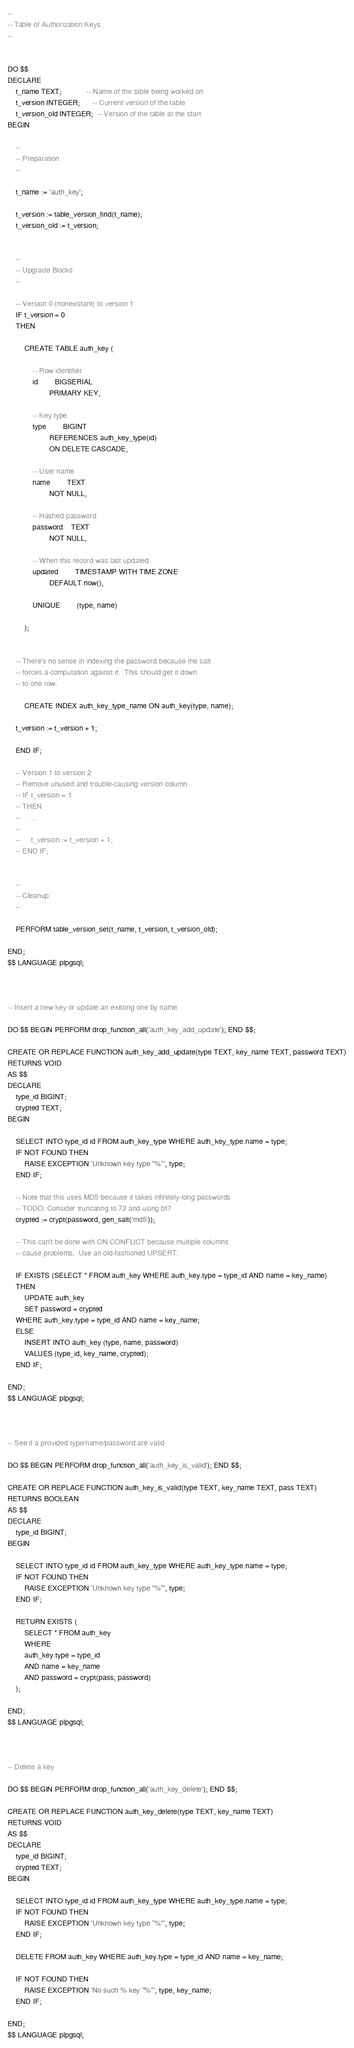Convert code to text. <code><loc_0><loc_0><loc_500><loc_500><_SQL_>--
-- Table of Authorization Keys
--


DO $$
DECLARE
    t_name TEXT;            -- Name of the table being worked on
    t_version INTEGER;      -- Current version of the table
    t_version_old INTEGER;  -- Version of the table at the start
BEGIN

    --
    -- Preparation
    --

    t_name := 'auth_key';

    t_version := table_version_find(t_name);
    t_version_old := t_version;


    --
    -- Upgrade Blocks
    --

    -- Version 0 (nonexistant) to version 1
    IF t_version = 0
    THEN

        CREATE TABLE auth_key (

        	-- Row identifier
        	id		BIGSERIAL
        			PRIMARY KEY,

        	-- Key type
        	type		BIGINT
        			REFERENCES auth_key_type(id)
        			ON DELETE CASCADE,

        	-- User name
        	name		TEXT
        			NOT NULL,

        	-- Hashed password
        	password	TEXT
        			NOT NULL,

        	-- When this record was last updated
        	updated		TIMESTAMP WITH TIME ZONE
        			DEFAULT now(),

        	UNIQUE		(type, name)

        );


	-- There's no sense in indexing the password because the salt
	-- forces a computation against it.  This should get it down
	-- to one row.

        CREATE INDEX auth_key_type_name ON auth_key(type, name);

	t_version := t_version + 1;

    END IF;

    -- Version 1 to version 2
    -- Remove unused and trouble-causing version column
    -- IF t_version = 1
    -- THEN
    --     ...
    -- 
    --     t_version := t_version + 1;
    -- END IF;


    --
    -- Cleanup
    --

    PERFORM table_version_set(t_name, t_version, t_version_old);

END;
$$ LANGUAGE plpgsql;



-- Insert a new key or update an existing one by name

DO $$ BEGIN PERFORM drop_function_all('auth_key_add_update'); END $$;

CREATE OR REPLACE FUNCTION auth_key_add_update(type TEXT, key_name TEXT, password TEXT)
RETURNS VOID
AS $$
DECLARE
    type_id BIGINT;
    crypted TEXT;
BEGIN

    SELECT INTO type_id id FROM auth_key_type WHERE auth_key_type.name = type;
    IF NOT FOUND THEN
        RAISE EXCEPTION 'Unknown key type "%"', type;
    END IF;

    -- Note that this uses MD5 because it takes infinitely-long passwords
    -- TODO: Consider truncating to 72 and using bf?
    crypted := crypt(password, gen_salt('md5'));

    -- This can't be done with ON CONFLICT because multiple columns
    -- cause problems.  Use an old-fashioned UPSERT.

    IF EXISTS (SELECT * FROM auth_key WHERE auth_key.type = type_id AND name = key_name)
    THEN
        UPDATE auth_key
        SET password = crypted
	WHERE auth_key.type = type_id AND name = key_name;
    ELSE
        INSERT INTO auth_key (type, name, password)
        VALUES (type_id, key_name, crypted);
    END IF;

END;
$$ LANGUAGE plpgsql;



-- See if a provided type/name/password are valid

DO $$ BEGIN PERFORM drop_function_all('auth_key_is_valid'); END $$;

CREATE OR REPLACE FUNCTION auth_key_is_valid(type TEXT, key_name TEXT, pass TEXT)
RETURNS BOOLEAN
AS $$
DECLARE
    type_id BIGINT;
BEGIN

    SELECT INTO type_id id FROM auth_key_type WHERE auth_key_type.name = type;
    IF NOT FOUND THEN
        RAISE EXCEPTION 'Unknown key type "%"', type;
    END IF;

    RETURN EXISTS (
        SELECT * FROM auth_key
        WHERE
	    auth_key.type = type_id
	    AND name = key_name
	    AND password = crypt(pass, password)
	);

END;
$$ LANGUAGE plpgsql;



-- Delete a key

DO $$ BEGIN PERFORM drop_function_all('auth_key_delete'); END $$;

CREATE OR REPLACE FUNCTION auth_key_delete(type TEXT, key_name TEXT)
RETURNS VOID
AS $$
DECLARE
    type_id BIGINT;
    crypted TEXT;
BEGIN

    SELECT INTO type_id id FROM auth_key_type WHERE auth_key_type.name = type;
    IF NOT FOUND THEN
        RAISE EXCEPTION 'Unknown key type "%"', type;
    END IF;

    DELETE FROM auth_key WHERE auth_key.type = type_id AND name = key_name;

    IF NOT FOUND THEN
        RAISE EXCEPTION 'No such % key "%"', type, key_name;
    END IF;

END;
$$ LANGUAGE plpgsql;
</code> 